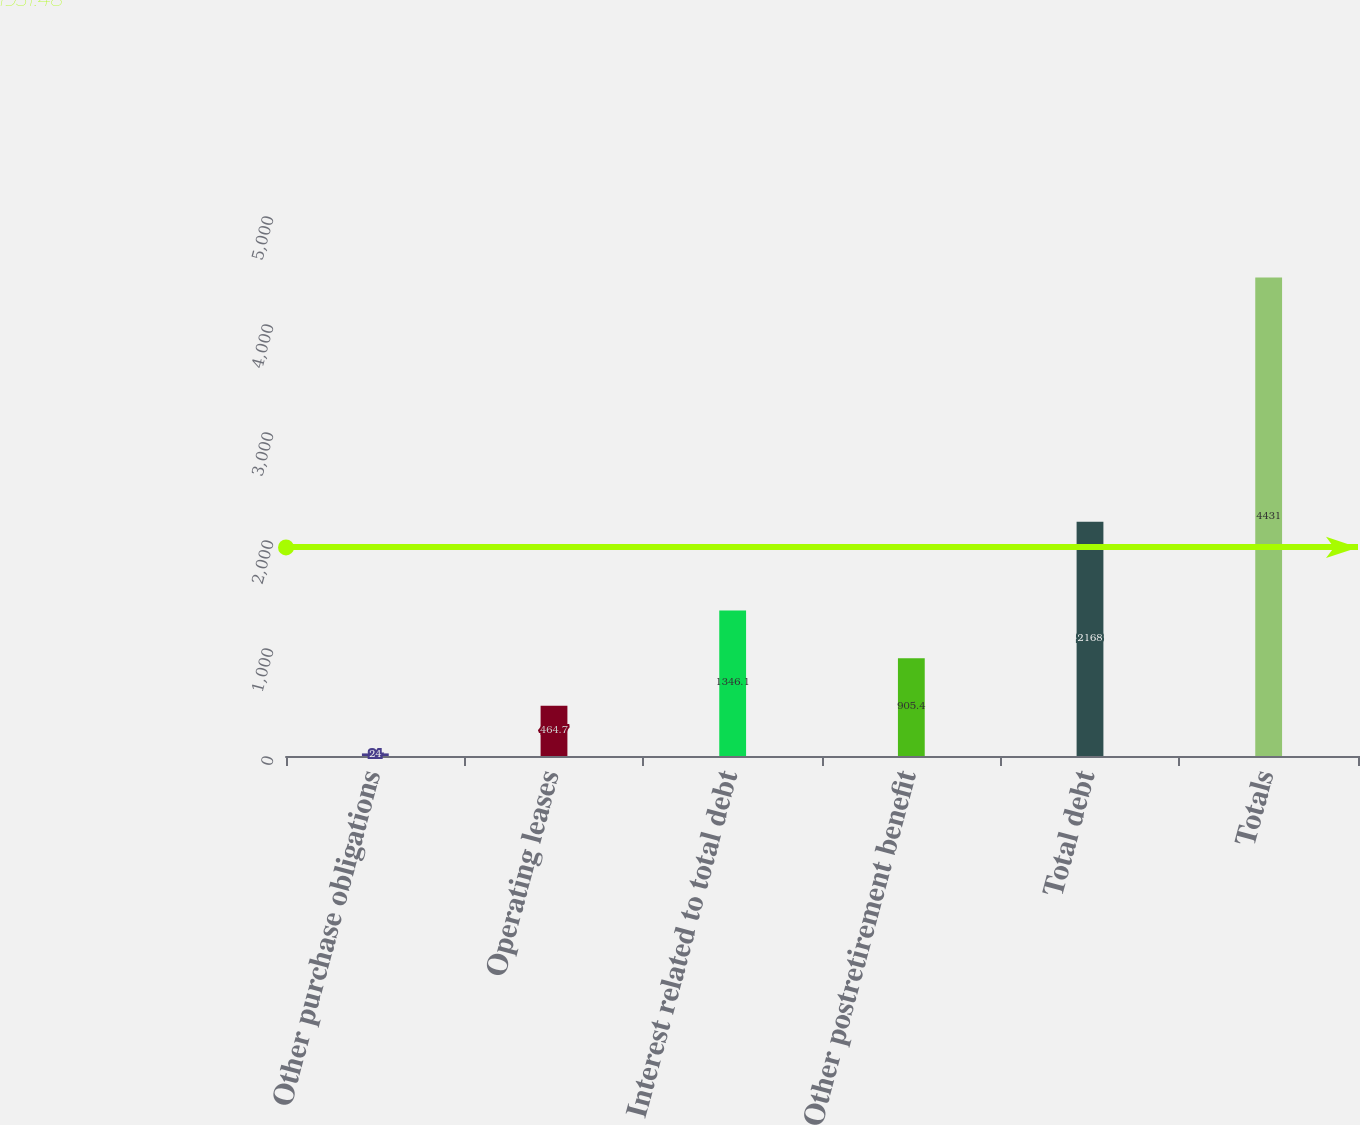Convert chart. <chart><loc_0><loc_0><loc_500><loc_500><bar_chart><fcel>Other purchase obligations<fcel>Operating leases<fcel>Interest related to total debt<fcel>Other postretirement benefit<fcel>Total debt<fcel>Totals<nl><fcel>24<fcel>464.7<fcel>1346.1<fcel>905.4<fcel>2168<fcel>4431<nl></chart> 